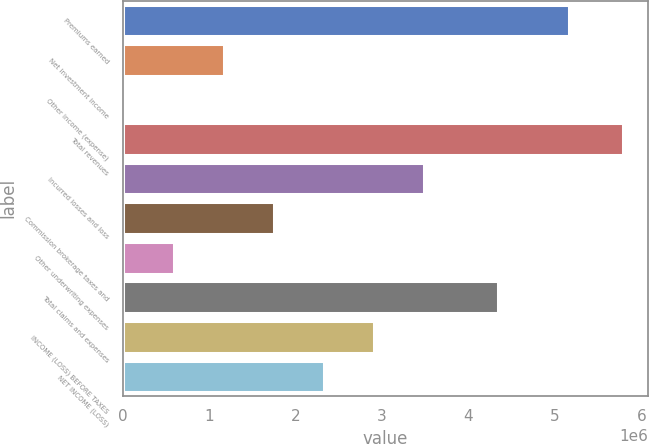Convert chart to OTSL. <chart><loc_0><loc_0><loc_500><loc_500><bar_chart><fcel>Premiums earned<fcel>Net investment income<fcel>Other income (expense)<fcel>Total revenues<fcel>Incurred losses and loss<fcel>Commission brokerage taxes and<fcel>Other underwriting expenses<fcel>Total claims and expenses<fcel>INCOME (LOSS) BEFORE TAXES<fcel>NET INCOME (LOSS)<nl><fcel>5.16914e+06<fcel>1.17287e+06<fcel>18437<fcel>5.79059e+06<fcel>3.48173e+06<fcel>1.75008e+06<fcel>595652<fcel>4.34447e+06<fcel>2.90451e+06<fcel>2.3273e+06<nl></chart> 